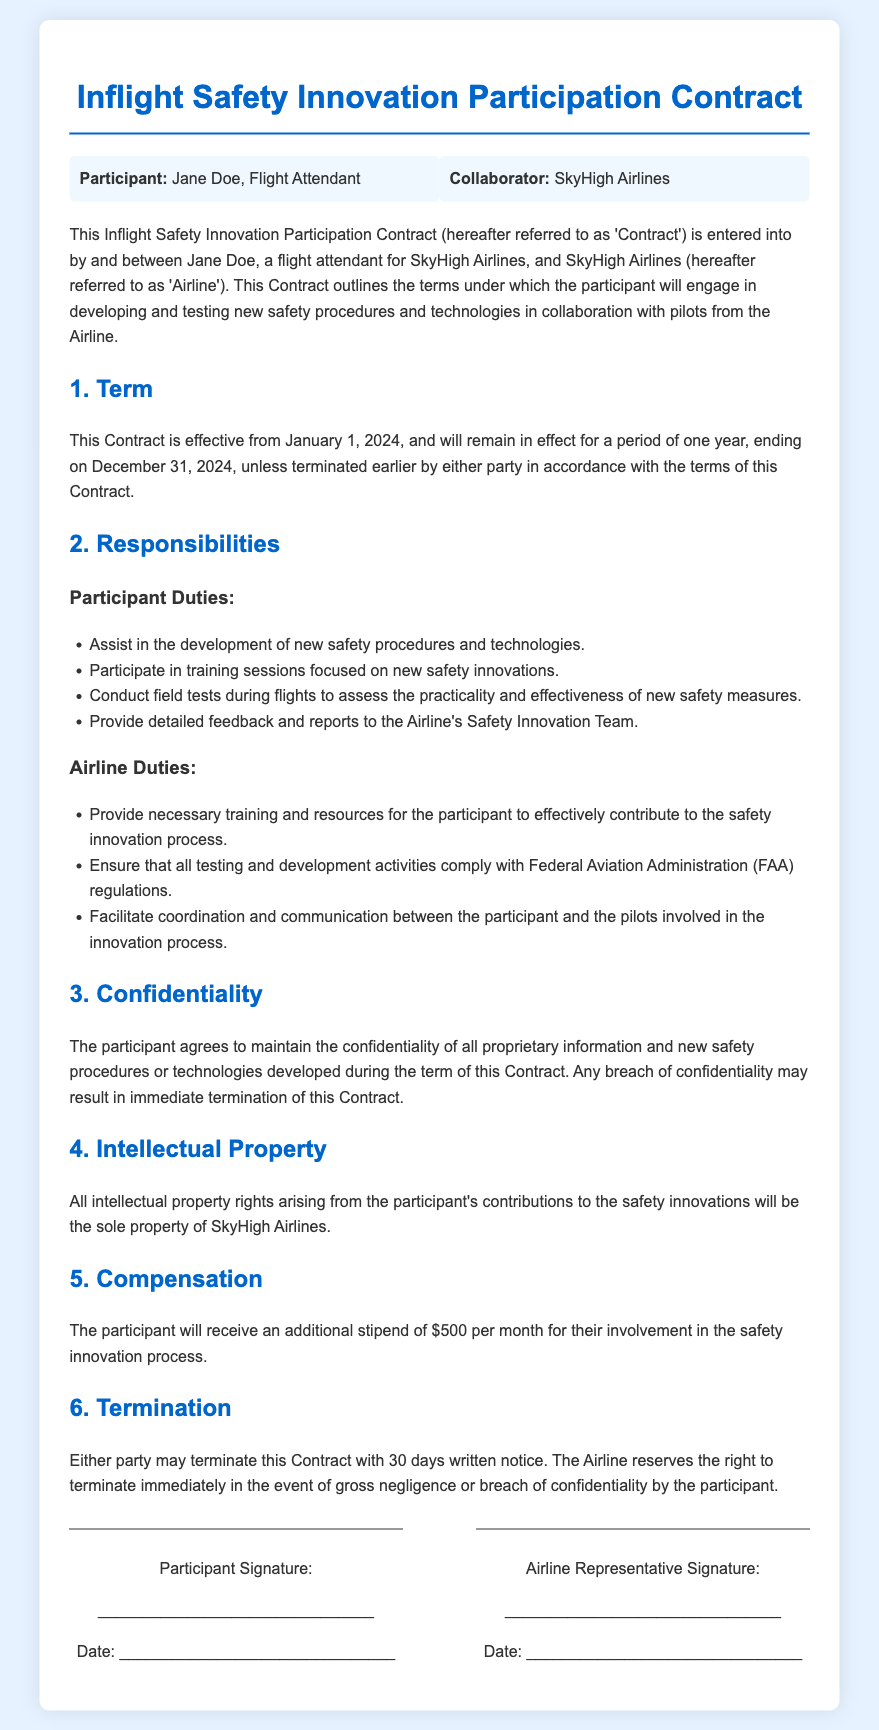What is the name of the participant? The participant's name is mentioned at the beginning of the contract.
Answer: Jane Doe What is the term length of the contract? The contract specifies that it is effective for a period of one year.
Answer: One year When does the contract begin? The contract states the effective date in the 'Term' section.
Answer: January 1, 2024 What is the monthly stipend for the participant? The stipend amount is indicated in the 'Compensation' section of the contract.
Answer: $500 What is a duty of the participant? The responsibilities of the participant are listed in the 'Responsibilities' section.
Answer: Conduct field tests during flights What can lead to immediate termination of the contract? The conditions for immediate termination are specified in the 'Termination' section.
Answer: Gross negligence or breach of confidentiality Who owns the intellectual property rights of the contributions? The 'Intellectual Property' section states who retains the rights for contributions made.
Answer: SkyHigh Airlines What is required for either party to terminate the contract? The 'Termination' section outlines the notice requirement for contract termination.
Answer: 30 days written notice 